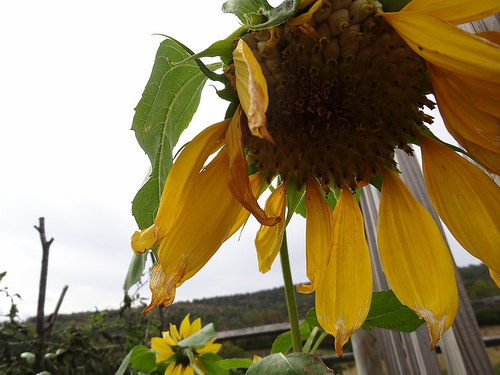<image>
Can you confirm if the petal is on the flower? Yes. Looking at the image, I can see the petal is positioned on top of the flower, with the flower providing support. Is the sunflower behind the fence? No. The sunflower is not behind the fence. From this viewpoint, the sunflower appears to be positioned elsewhere in the scene. 